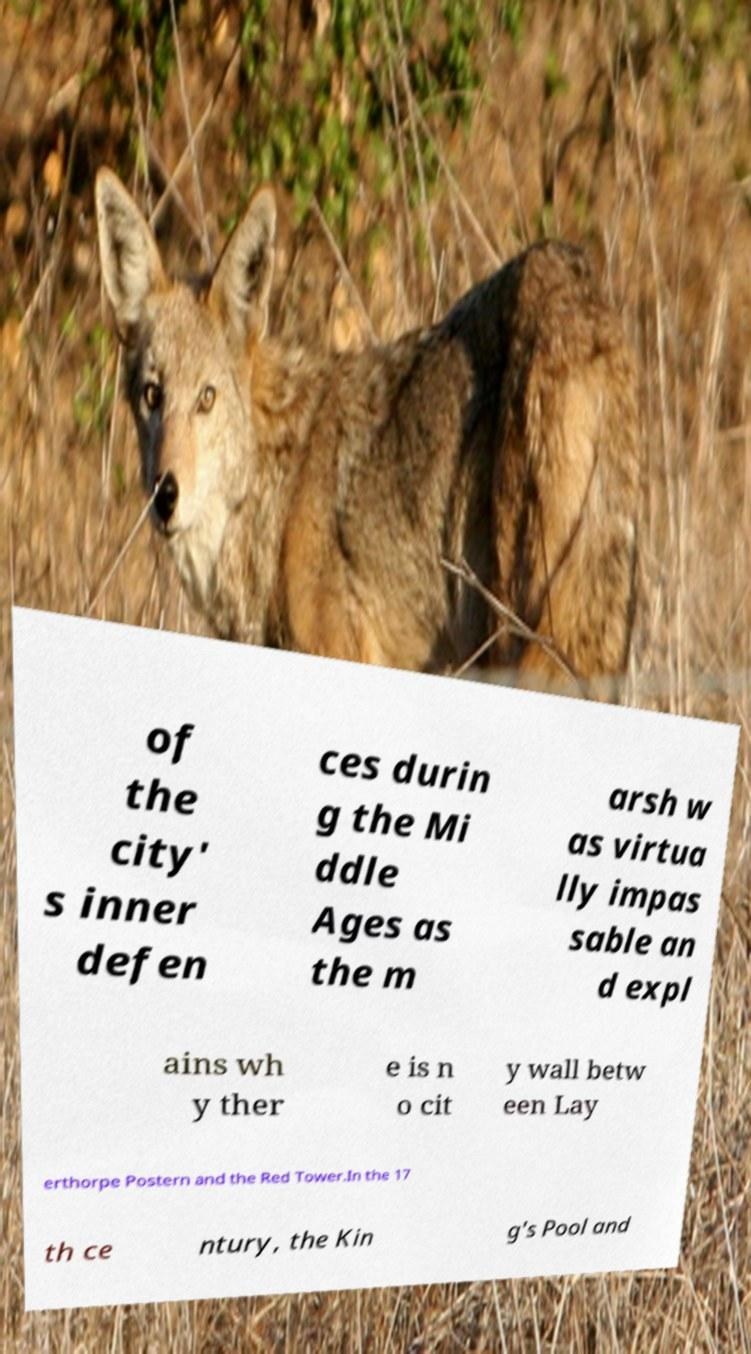Please identify and transcribe the text found in this image. of the city' s inner defen ces durin g the Mi ddle Ages as the m arsh w as virtua lly impas sable an d expl ains wh y ther e is n o cit y wall betw een Lay erthorpe Postern and the Red Tower.In the 17 th ce ntury, the Kin g's Pool and 